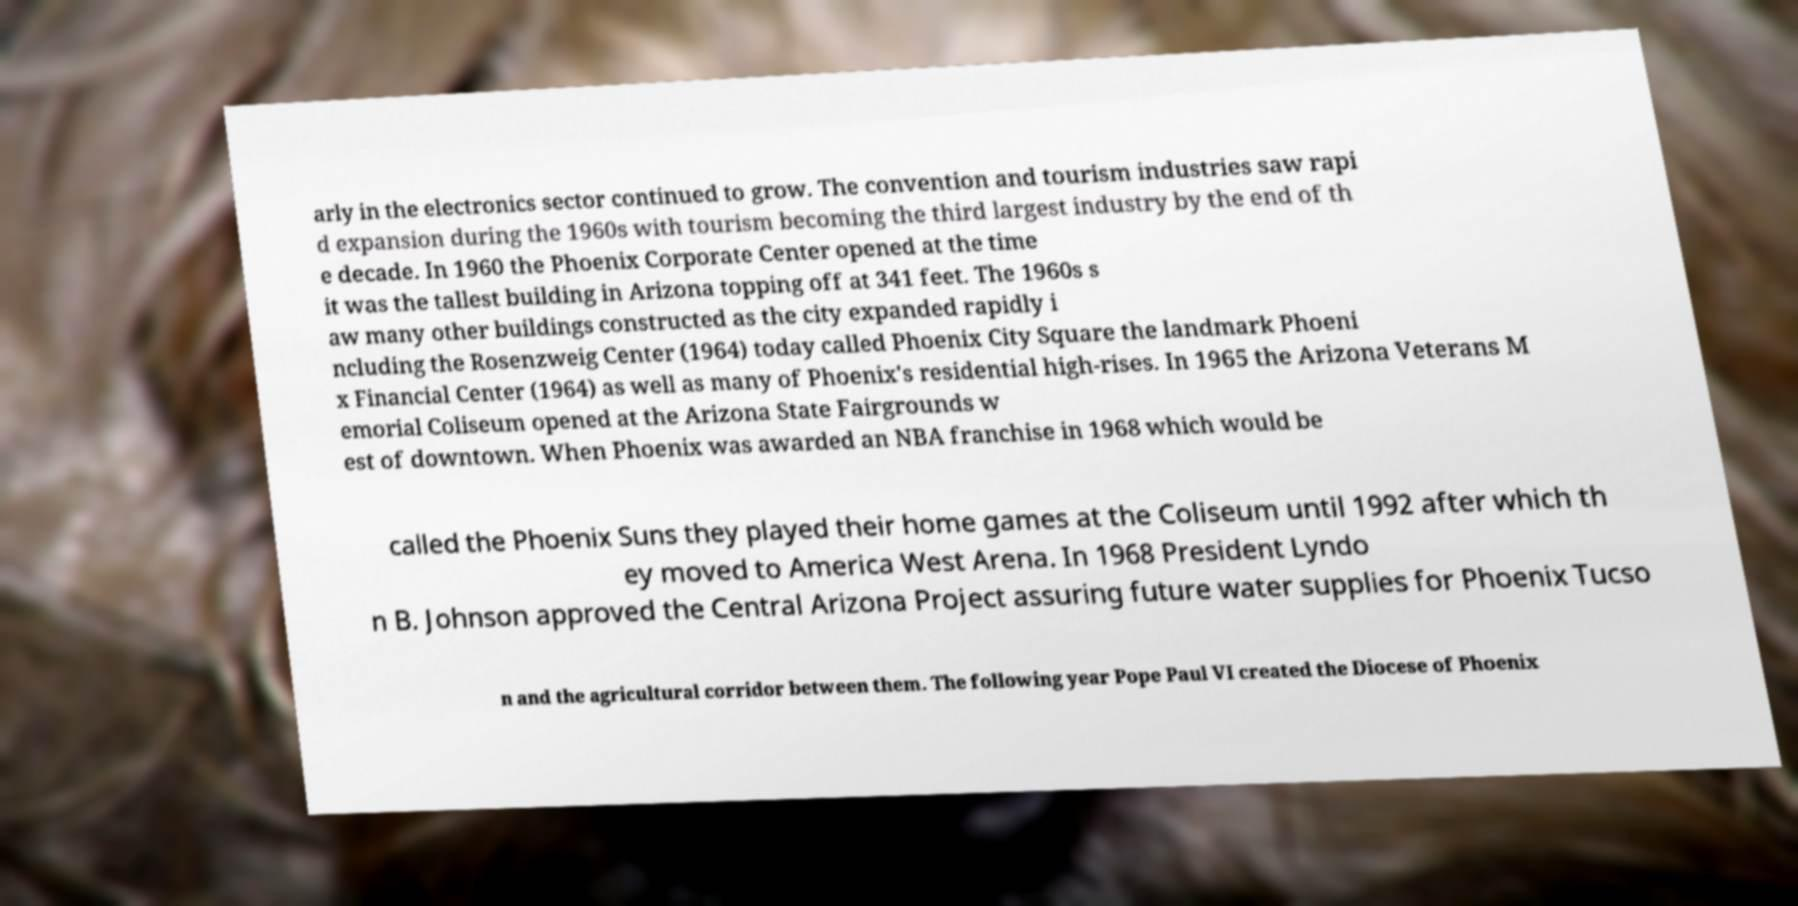Please read and relay the text visible in this image. What does it say? arly in the electronics sector continued to grow. The convention and tourism industries saw rapi d expansion during the 1960s with tourism becoming the third largest industry by the end of th e decade. In 1960 the Phoenix Corporate Center opened at the time it was the tallest building in Arizona topping off at 341 feet. The 1960s s aw many other buildings constructed as the city expanded rapidly i ncluding the Rosenzweig Center (1964) today called Phoenix City Square the landmark Phoeni x Financial Center (1964) as well as many of Phoenix's residential high-rises. In 1965 the Arizona Veterans M emorial Coliseum opened at the Arizona State Fairgrounds w est of downtown. When Phoenix was awarded an NBA franchise in 1968 which would be called the Phoenix Suns they played their home games at the Coliseum until 1992 after which th ey moved to America West Arena. In 1968 President Lyndo n B. Johnson approved the Central Arizona Project assuring future water supplies for Phoenix Tucso n and the agricultural corridor between them. The following year Pope Paul VI created the Diocese of Phoenix 